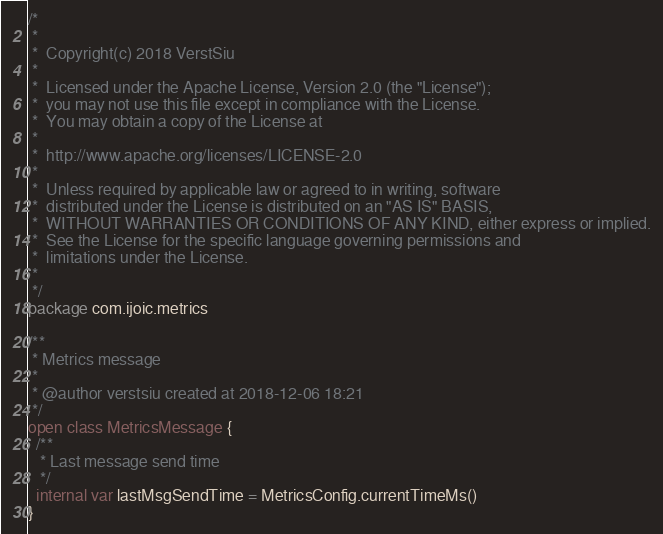Convert code to text. <code><loc_0><loc_0><loc_500><loc_500><_Kotlin_>/*
 *
 *  Copyright(c) 2018 VerstSiu
 *
 *  Licensed under the Apache License, Version 2.0 (the "License");
 *  you may not use this file except in compliance with the License.
 *  You may obtain a copy of the License at
 *
 *  http://www.apache.org/licenses/LICENSE-2.0
 *
 *  Unless required by applicable law or agreed to in writing, software
 *  distributed under the License is distributed on an "AS IS" BASIS,
 *  WITHOUT WARRANTIES OR CONDITIONS OF ANY KIND, either express or implied.
 *  See the License for the specific language governing permissions and
 *  limitations under the License.
 *
 */
package com.ijoic.metrics

/**
 * Metrics message
 *
 * @author verstsiu created at 2018-12-06 18:21
 */
open class MetricsMessage {
  /**
   * Last message send time
   */
  internal var lastMsgSendTime = MetricsConfig.currentTimeMs()
}</code> 